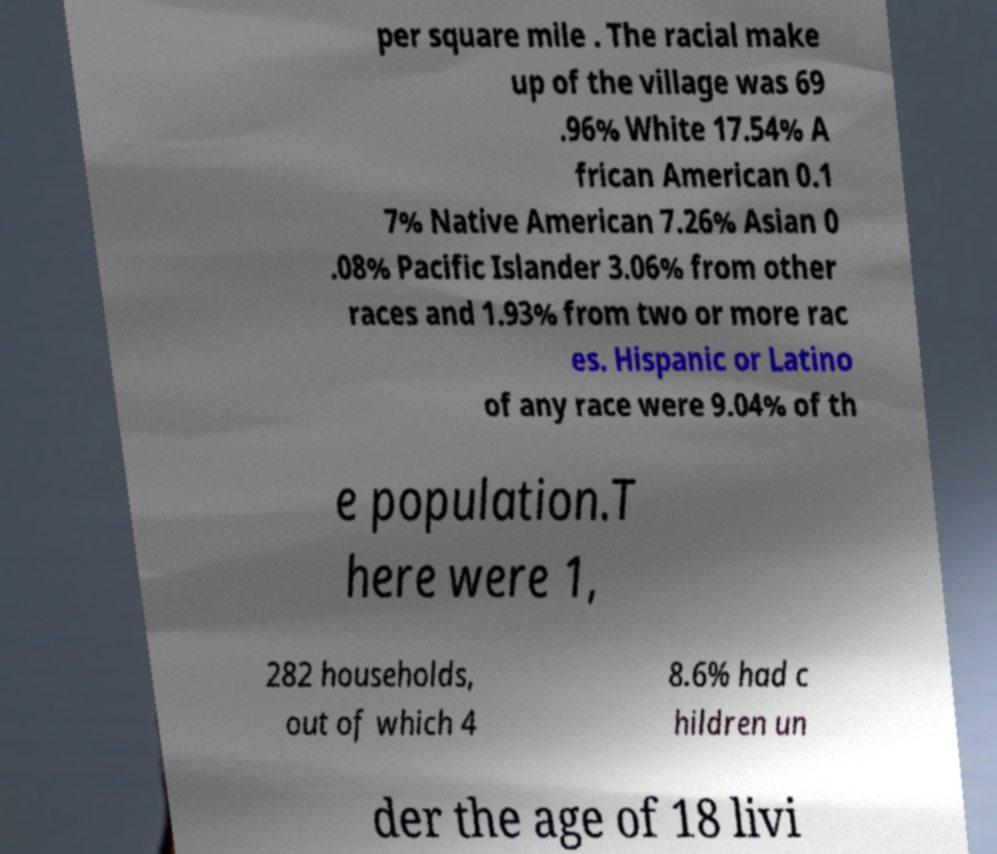Please read and relay the text visible in this image. What does it say? per square mile . The racial make up of the village was 69 .96% White 17.54% A frican American 0.1 7% Native American 7.26% Asian 0 .08% Pacific Islander 3.06% from other races and 1.93% from two or more rac es. Hispanic or Latino of any race were 9.04% of th e population.T here were 1, 282 households, out of which 4 8.6% had c hildren un der the age of 18 livi 